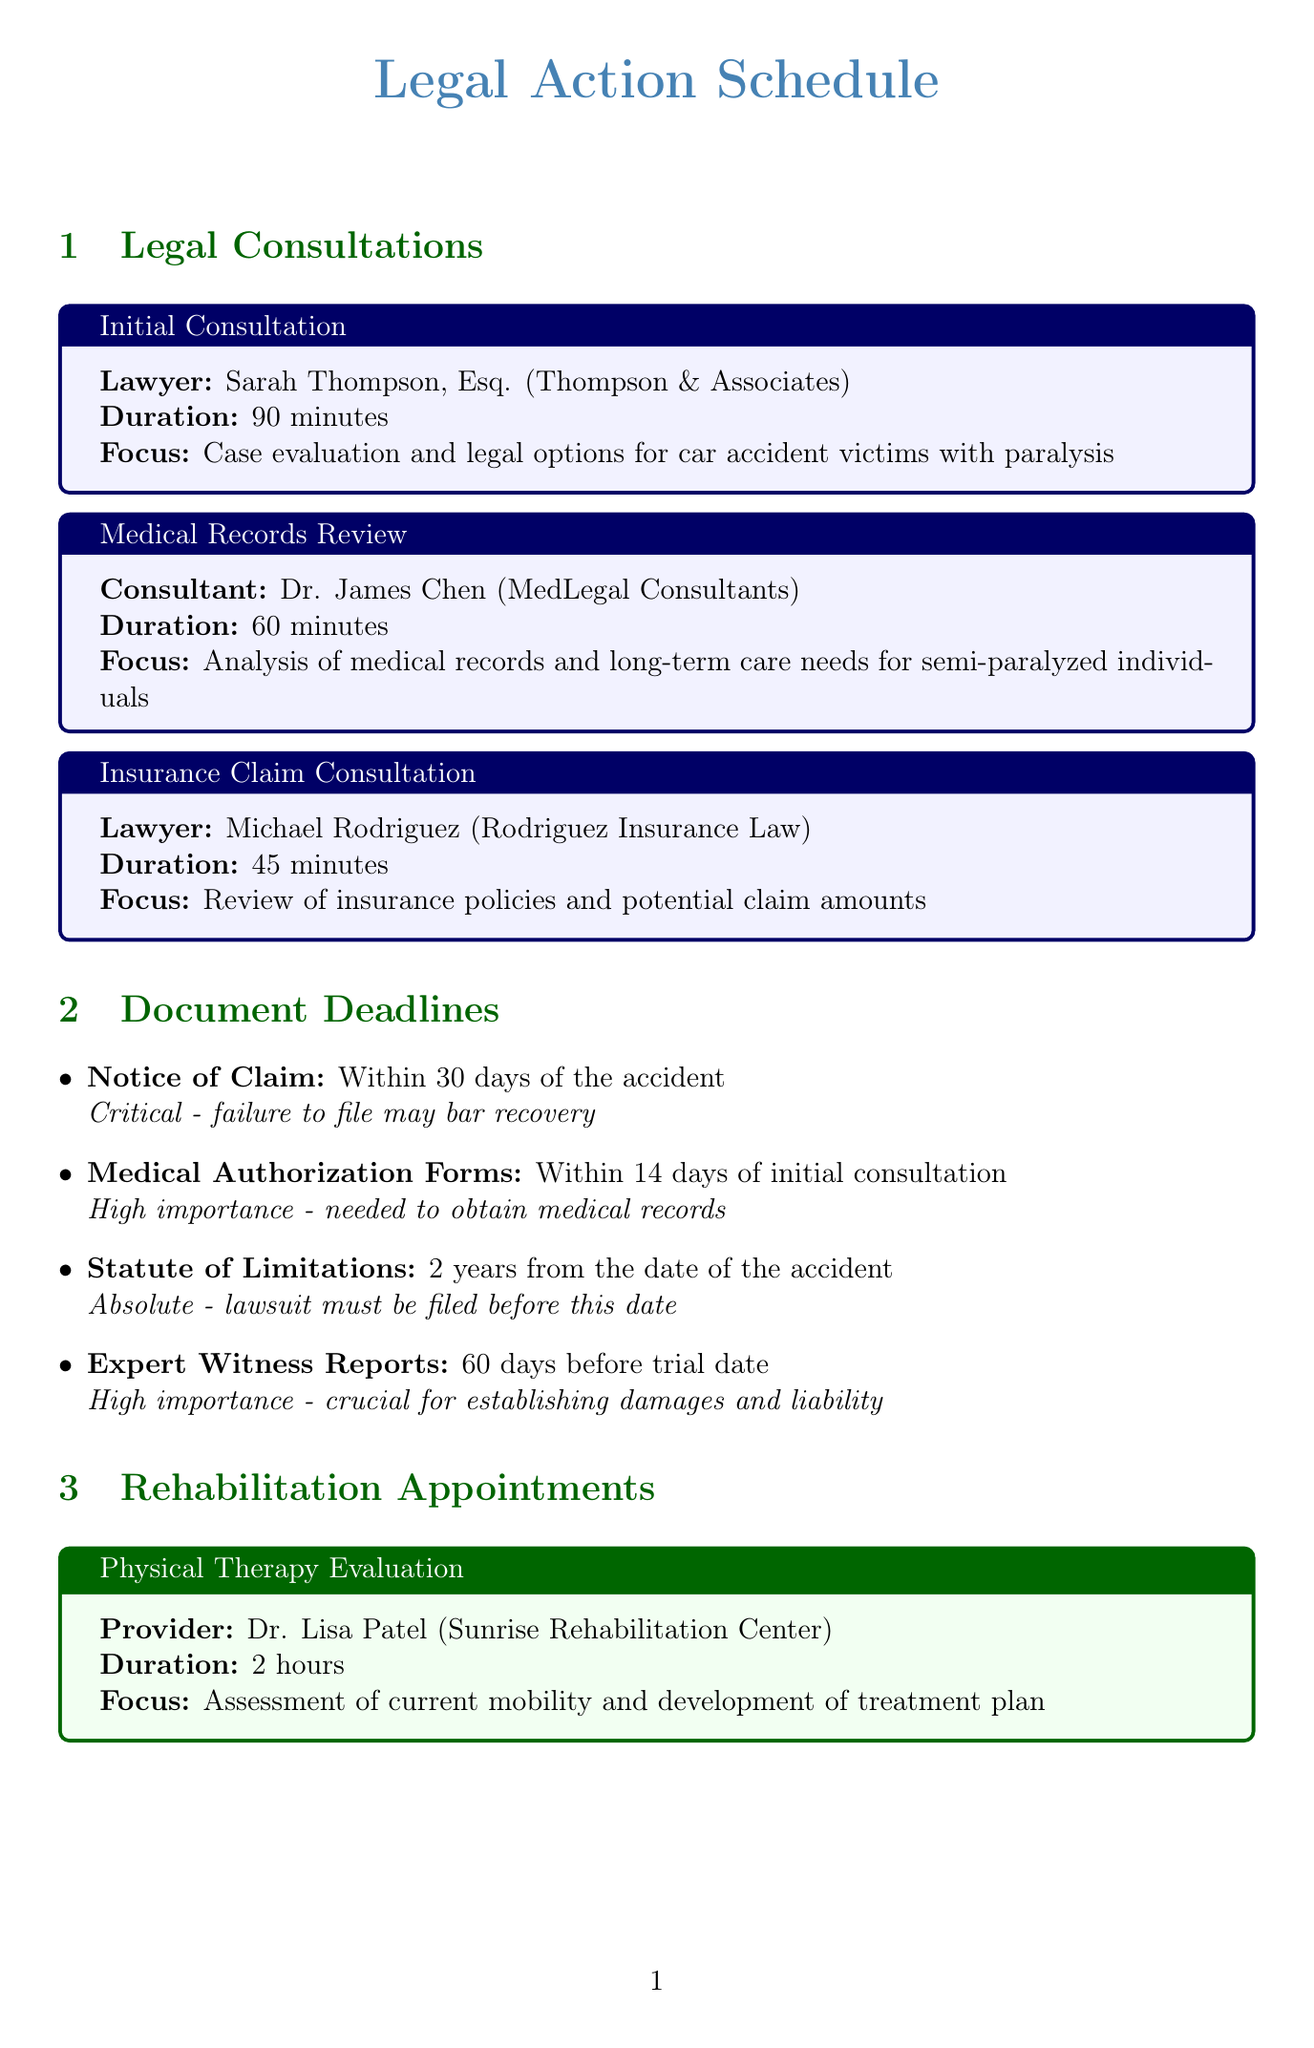What is the name of the initial consultation lawyer? The lawyer for the initial consultation is identified in the document as Sarah Thompson, Esq.
Answer: Sarah Thompson, Esq How long is the Medical Records Review consultation? The duration of the Medical Records Review is specified as 60 minutes.
Answer: 60 minutes What is the deadline for filing the Notice of Claim? The document states that the Notice of Claim must be filed within 30 days of the accident.
Answer: Within 30 days of the accident What is required 14 days after the initial consultation? According to the document, Medical Authorization Forms are required within 14 days of the initial consultation.
Answer: Medical Authorization Forms What is the focus of the Occupational Therapy Session? The document specifies that the focus of the Occupational Therapy Session is on techniques for daily living activities with partial paralysis.
Answer: Techniques for daily living activities with partial paralysis How many hours is the Home Accessibility Assessment? The Home Accessibility Assessment is mentioned as lasting 3 hours.
Answer: 3 hours What is the purpose of the Expert Witness Reports? The document details that Expert Witness Reports are crucial for establishing damages and liability.
Answer: Establishing damages and liability Which facility provides Psychological Support? The facility mentioned for Psychological Support is Mind & Body Wellness Center.
Answer: Mind & Body Wellness Center What is the duration of the Physical Therapy Evaluation? The duration for the Physical Therapy Evaluation is stated as 2 hours.
Answer: 2 hours 